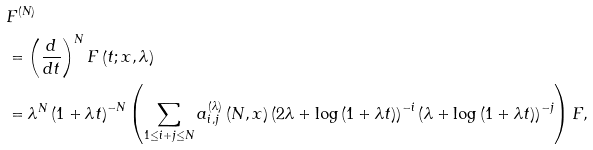<formula> <loc_0><loc_0><loc_500><loc_500>& F ^ { \left ( N \right ) } \\ & = \left ( \frac { d } { d t } \right ) ^ { N } F \left ( t ; x , \lambda \right ) \\ & = \lambda ^ { N } \left ( 1 + \lambda t \right ) ^ { - N } \left ( \sum _ { 1 \leq i + j \leq N } a _ { i , j } ^ { \left ( \lambda \right ) } \left ( N , x \right ) \left ( 2 \lambda + \log \left ( 1 + \lambda t \right ) \right ) ^ { - i } \left ( \lambda + \log \left ( 1 + \lambda t \right ) \right ) ^ { - j } \right ) F ,</formula> 